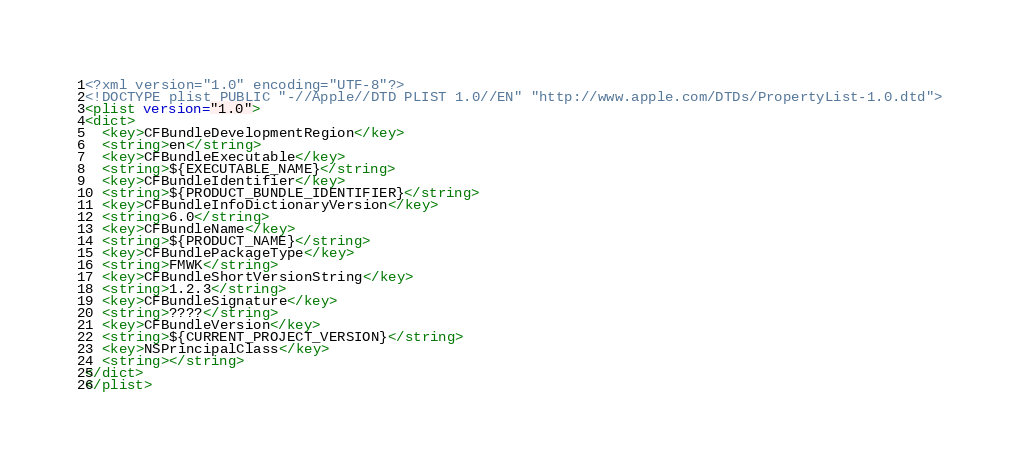Convert code to text. <code><loc_0><loc_0><loc_500><loc_500><_XML_><?xml version="1.0" encoding="UTF-8"?>
<!DOCTYPE plist PUBLIC "-//Apple//DTD PLIST 1.0//EN" "http://www.apple.com/DTDs/PropertyList-1.0.dtd">
<plist version="1.0">
<dict>
  <key>CFBundleDevelopmentRegion</key>
  <string>en</string>
  <key>CFBundleExecutable</key>
  <string>${EXECUTABLE_NAME}</string>
  <key>CFBundleIdentifier</key>
  <string>${PRODUCT_BUNDLE_IDENTIFIER}</string>
  <key>CFBundleInfoDictionaryVersion</key>
  <string>6.0</string>
  <key>CFBundleName</key>
  <string>${PRODUCT_NAME}</string>
  <key>CFBundlePackageType</key>
  <string>FMWK</string>
  <key>CFBundleShortVersionString</key>
  <string>1.2.3</string>
  <key>CFBundleSignature</key>
  <string>????</string>
  <key>CFBundleVersion</key>
  <string>${CURRENT_PROJECT_VERSION}</string>
  <key>NSPrincipalClass</key>
  <string></string>
</dict>
</plist>
</code> 